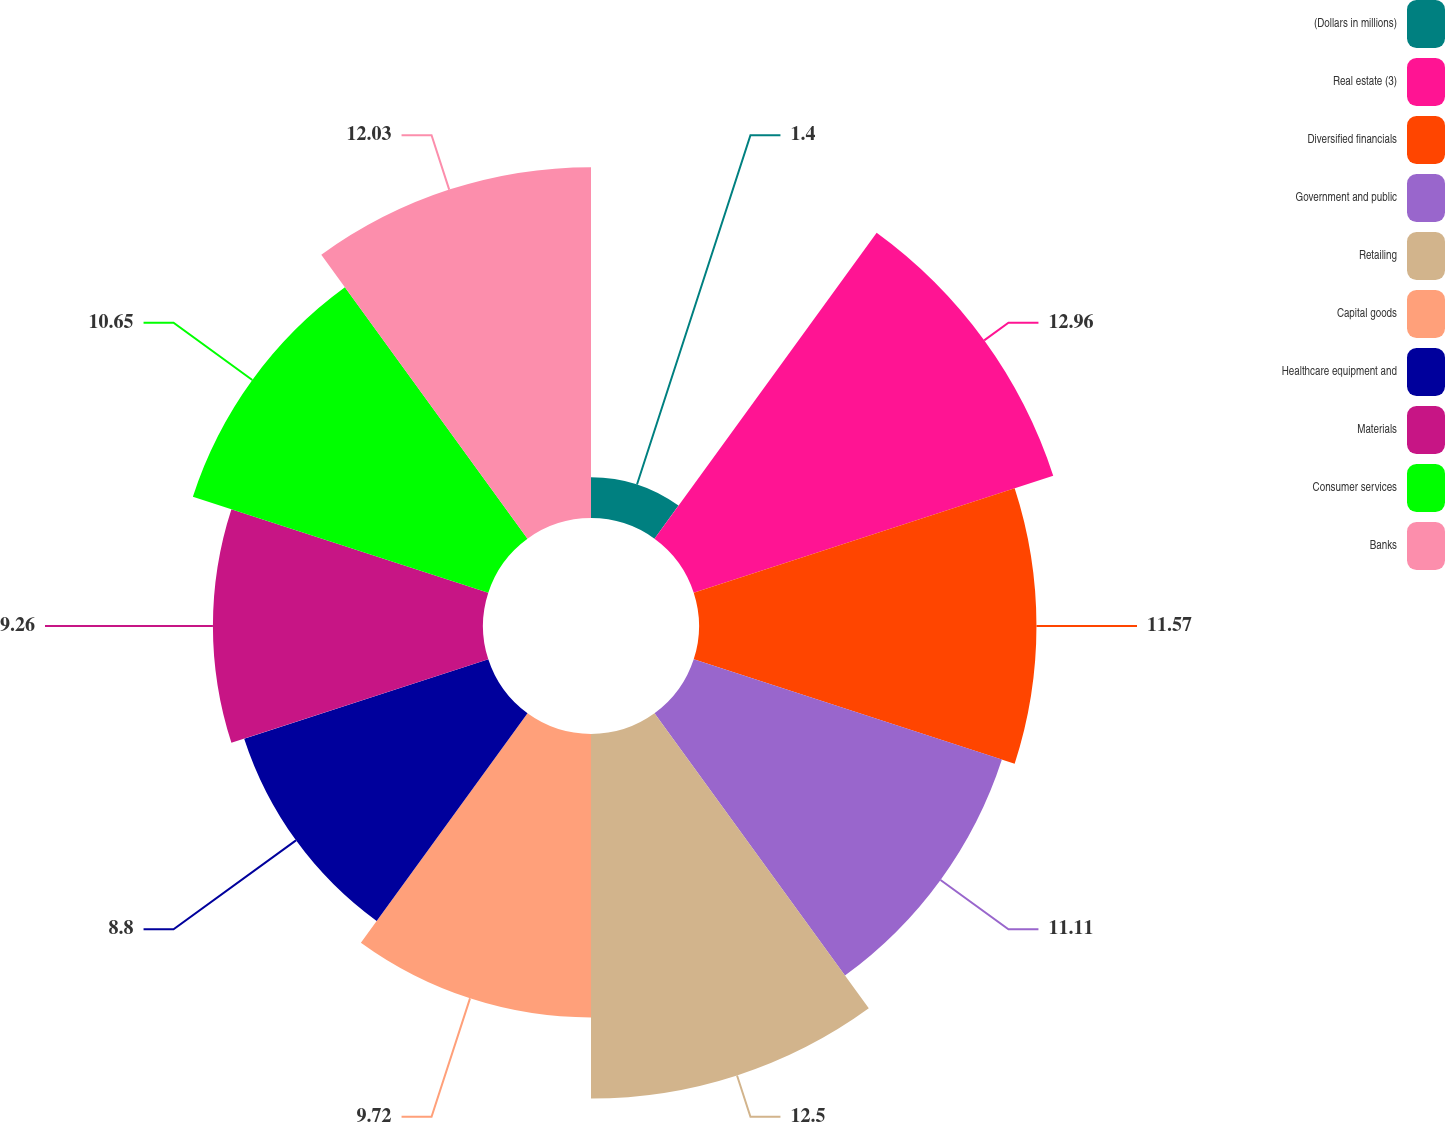Convert chart to OTSL. <chart><loc_0><loc_0><loc_500><loc_500><pie_chart><fcel>(Dollars in millions)<fcel>Real estate (3)<fcel>Diversified financials<fcel>Government and public<fcel>Retailing<fcel>Capital goods<fcel>Healthcare equipment and<fcel>Materials<fcel>Consumer services<fcel>Banks<nl><fcel>1.4%<fcel>12.96%<fcel>11.57%<fcel>11.11%<fcel>12.5%<fcel>9.72%<fcel>8.8%<fcel>9.26%<fcel>10.65%<fcel>12.03%<nl></chart> 